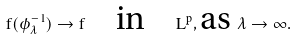<formula> <loc_0><loc_0><loc_500><loc_500>f ( \phi ^ { - 1 } _ { \lambda } ) \to f \quad \text {in} \quad L ^ { p } , \text {as } \lambda \to \infty .</formula> 